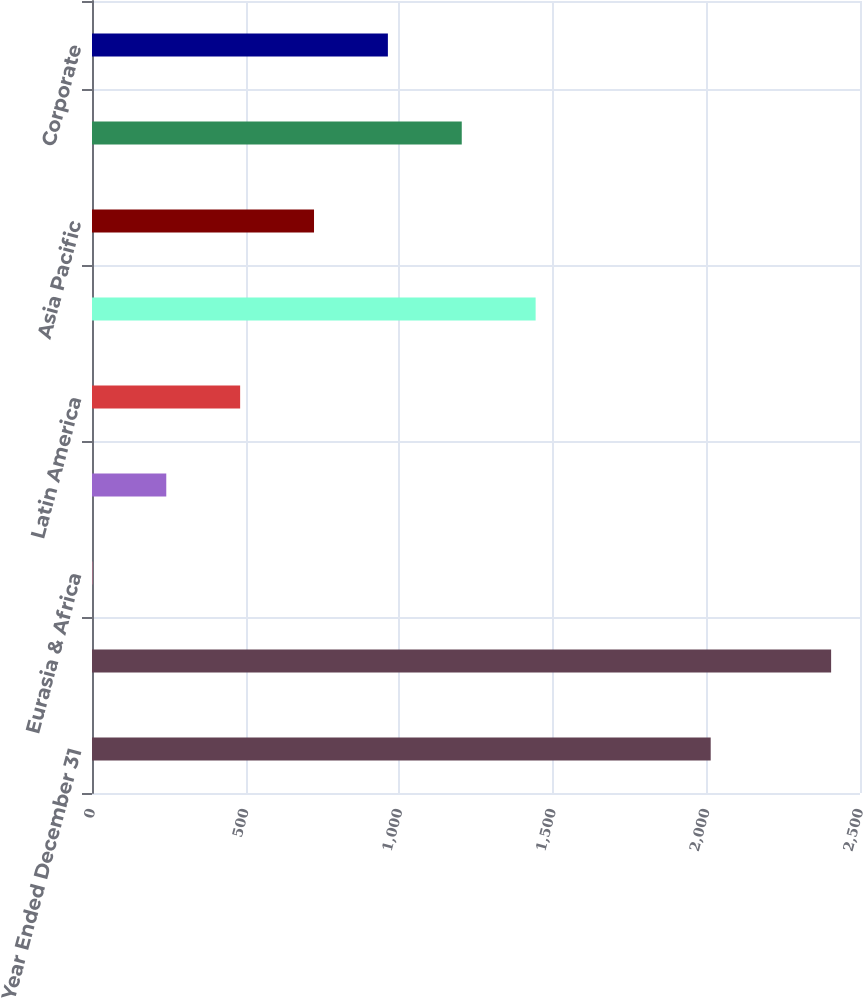<chart> <loc_0><loc_0><loc_500><loc_500><bar_chart><fcel>Year Ended December 31<fcel>Capital expenditures<fcel>Eurasia & Africa<fcel>Europe<fcel>Latin America<fcel>North America<fcel>Asia Pacific<fcel>Bottling Investments<fcel>Corporate<nl><fcel>2014<fcel>2406<fcel>1.3<fcel>241.77<fcel>482.24<fcel>1444.12<fcel>722.71<fcel>1203.65<fcel>963.18<nl></chart> 